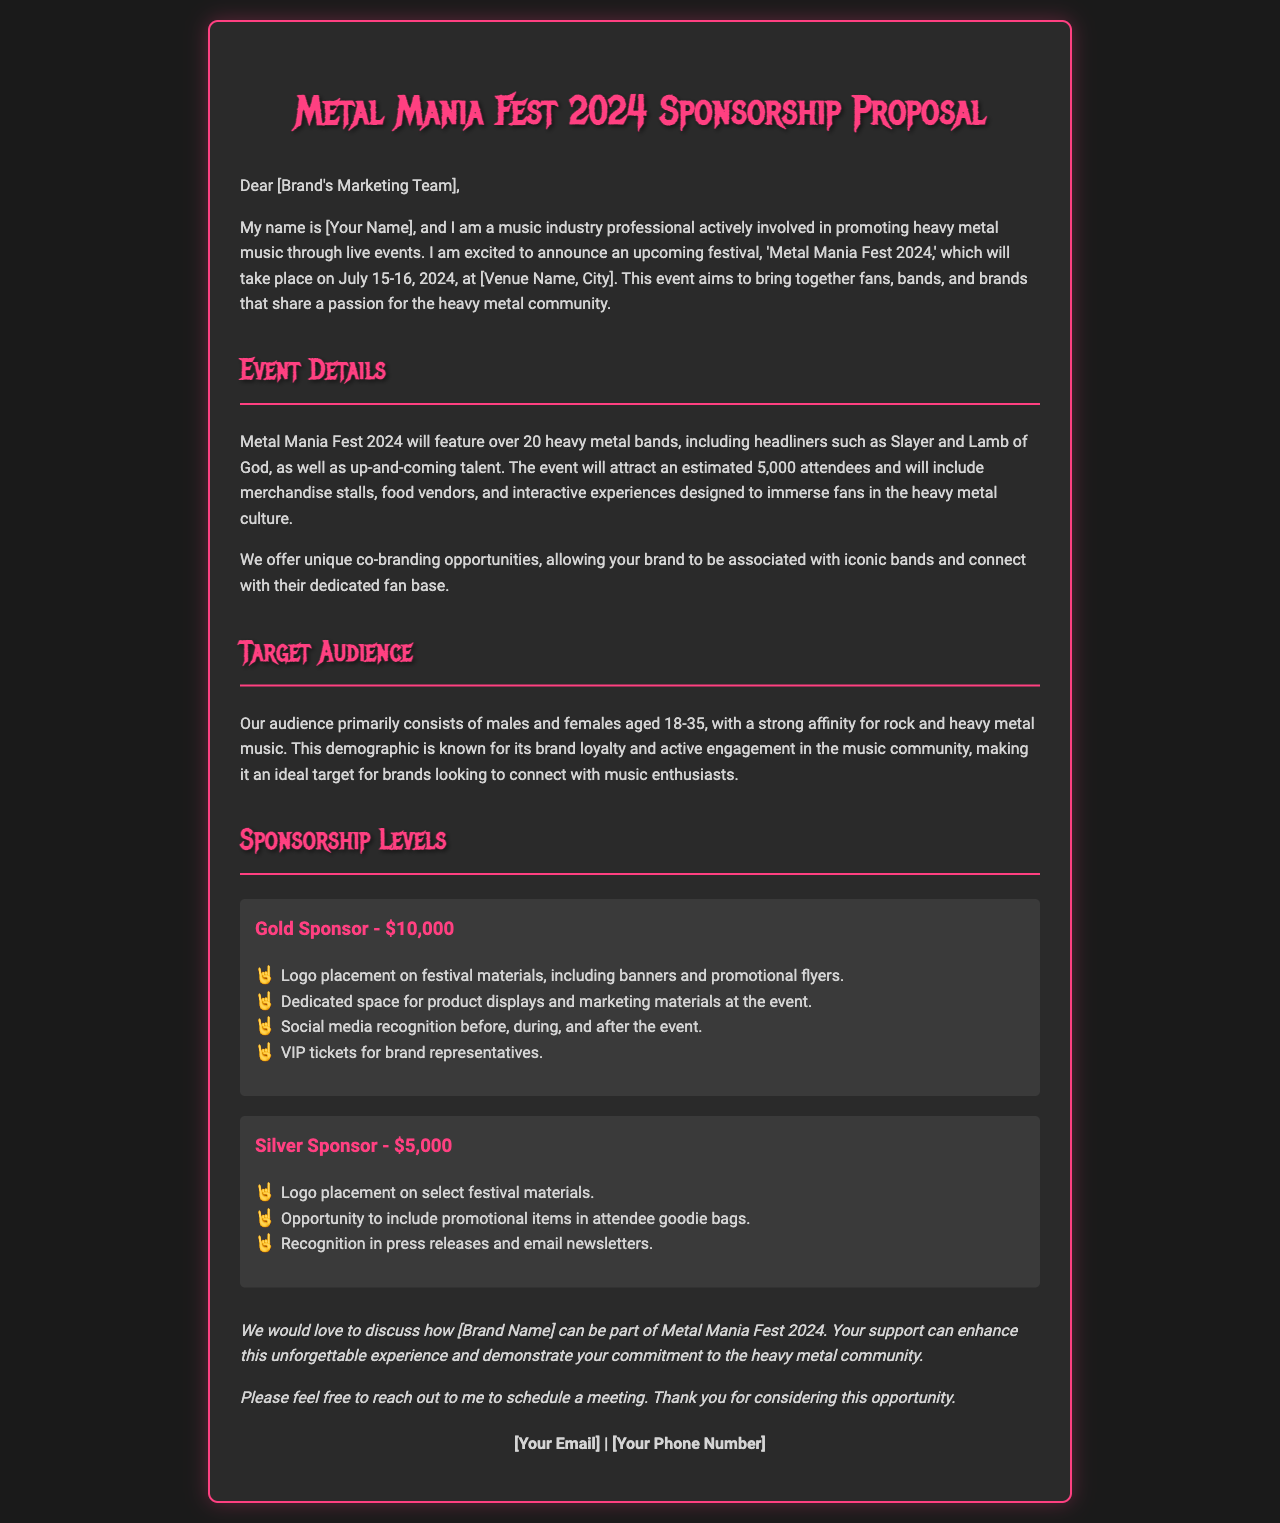What is the name of the festival? The document states that the festival is called 'Metal Mania Fest 2024.'
Answer: Metal Mania Fest 2024 What are the dates of the event? The event is scheduled to take place on July 15-16, 2024.
Answer: July 15-16, 2024 How many bands will perform at the festival? The document mentions that over 20 heavy metal bands will perform at the festival.
Answer: Over 20 What is the estimated number of attendees? The estimated attendance for the festival is stated as 5,000 attendees.
Answer: 5,000 What is the sponsorship level for logo placement on festival materials? The Gold Sponsor level includes logo placement on festival materials.
Answer: Gold Sponsor What is the financial contribution for a Silver Sponsor? The document specifies that the Silver Sponsor level has a contribution of $5,000.
Answer: $5,000 What age group is the primary audience for the festival? The document indicates that the primary audience consists of individuals aged 18-35.
Answer: 18-35 What type of recognition will sponsors receive on social media? The Gold Sponsor will receive social media recognition before, during, and after the event.
Answer: Social media recognition What is the name of the venue for the event? The document suggests that the venue name will be provided but does not specify it.
Answer: [Venue Name, City] 